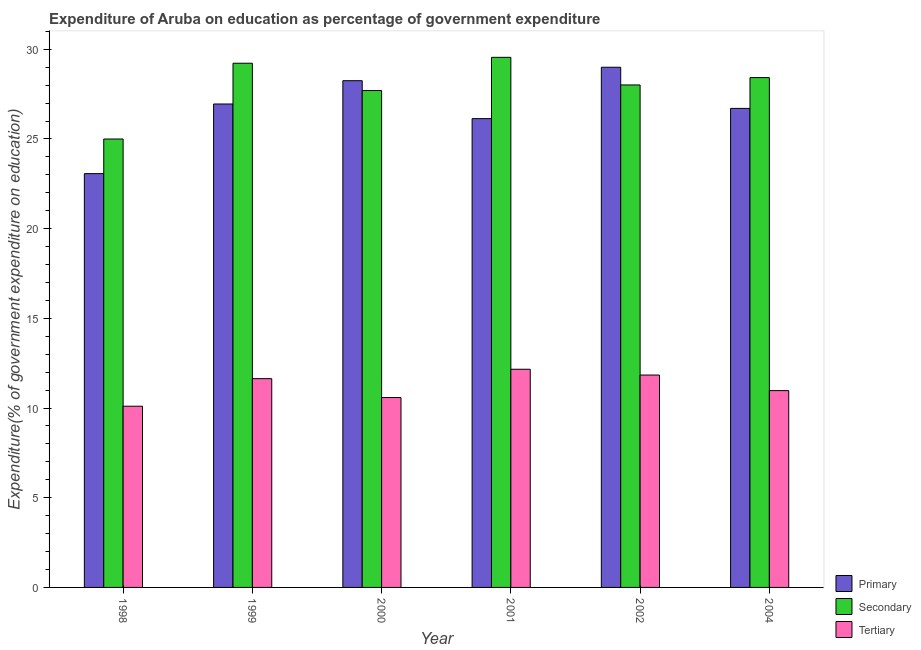Are the number of bars on each tick of the X-axis equal?
Keep it short and to the point. Yes. What is the label of the 6th group of bars from the left?
Your answer should be very brief. 2004. In how many cases, is the number of bars for a given year not equal to the number of legend labels?
Give a very brief answer. 0. What is the expenditure on secondary education in 2000?
Offer a terse response. 27.7. Across all years, what is the maximum expenditure on tertiary education?
Ensure brevity in your answer.  12.16. Across all years, what is the minimum expenditure on secondary education?
Your answer should be compact. 25. In which year was the expenditure on tertiary education maximum?
Your response must be concise. 2001. What is the total expenditure on secondary education in the graph?
Provide a short and direct response. 167.9. What is the difference between the expenditure on secondary education in 2000 and that in 2004?
Your answer should be very brief. -0.72. What is the difference between the expenditure on primary education in 2004 and the expenditure on secondary education in 2002?
Ensure brevity in your answer.  -2.29. What is the average expenditure on tertiary education per year?
Provide a short and direct response. 11.22. What is the ratio of the expenditure on primary education in 1999 to that in 2000?
Your answer should be compact. 0.95. Is the difference between the expenditure on tertiary education in 2000 and 2002 greater than the difference between the expenditure on secondary education in 2000 and 2002?
Offer a terse response. No. What is the difference between the highest and the second highest expenditure on primary education?
Make the answer very short. 0.75. What is the difference between the highest and the lowest expenditure on tertiary education?
Provide a succinct answer. 2.06. Is the sum of the expenditure on tertiary education in 2002 and 2004 greater than the maximum expenditure on secondary education across all years?
Your answer should be compact. Yes. What does the 3rd bar from the left in 2004 represents?
Ensure brevity in your answer.  Tertiary. What does the 2nd bar from the right in 1999 represents?
Your response must be concise. Secondary. Is it the case that in every year, the sum of the expenditure on primary education and expenditure on secondary education is greater than the expenditure on tertiary education?
Your answer should be very brief. Yes. Are all the bars in the graph horizontal?
Ensure brevity in your answer.  No. How many years are there in the graph?
Provide a short and direct response. 6. What is the difference between two consecutive major ticks on the Y-axis?
Give a very brief answer. 5. Where does the legend appear in the graph?
Give a very brief answer. Bottom right. How are the legend labels stacked?
Offer a very short reply. Vertical. What is the title of the graph?
Provide a short and direct response. Expenditure of Aruba on education as percentage of government expenditure. What is the label or title of the X-axis?
Keep it short and to the point. Year. What is the label or title of the Y-axis?
Provide a short and direct response. Expenditure(% of government expenditure on education). What is the Expenditure(% of government expenditure on education) of Primary in 1998?
Your response must be concise. 23.07. What is the Expenditure(% of government expenditure on education) in Secondary in 1998?
Provide a short and direct response. 25. What is the Expenditure(% of government expenditure on education) of Tertiary in 1998?
Make the answer very short. 10.1. What is the Expenditure(% of government expenditure on education) in Primary in 1999?
Make the answer very short. 26.95. What is the Expenditure(% of government expenditure on education) of Secondary in 1999?
Ensure brevity in your answer.  29.22. What is the Expenditure(% of government expenditure on education) of Tertiary in 1999?
Offer a very short reply. 11.64. What is the Expenditure(% of government expenditure on education) in Primary in 2000?
Keep it short and to the point. 28.25. What is the Expenditure(% of government expenditure on education) in Secondary in 2000?
Offer a very short reply. 27.7. What is the Expenditure(% of government expenditure on education) in Tertiary in 2000?
Keep it short and to the point. 10.58. What is the Expenditure(% of government expenditure on education) of Primary in 2001?
Provide a short and direct response. 26.13. What is the Expenditure(% of government expenditure on education) of Secondary in 2001?
Your response must be concise. 29.55. What is the Expenditure(% of government expenditure on education) in Tertiary in 2001?
Provide a succinct answer. 12.16. What is the Expenditure(% of government expenditure on education) in Primary in 2002?
Your response must be concise. 29. What is the Expenditure(% of government expenditure on education) in Secondary in 2002?
Your answer should be very brief. 28.01. What is the Expenditure(% of government expenditure on education) in Tertiary in 2002?
Keep it short and to the point. 11.84. What is the Expenditure(% of government expenditure on education) of Primary in 2004?
Make the answer very short. 26.7. What is the Expenditure(% of government expenditure on education) in Secondary in 2004?
Make the answer very short. 28.42. What is the Expenditure(% of government expenditure on education) of Tertiary in 2004?
Give a very brief answer. 10.97. Across all years, what is the maximum Expenditure(% of government expenditure on education) of Primary?
Your answer should be very brief. 29. Across all years, what is the maximum Expenditure(% of government expenditure on education) of Secondary?
Your answer should be compact. 29.55. Across all years, what is the maximum Expenditure(% of government expenditure on education) in Tertiary?
Your response must be concise. 12.16. Across all years, what is the minimum Expenditure(% of government expenditure on education) of Primary?
Provide a short and direct response. 23.07. Across all years, what is the minimum Expenditure(% of government expenditure on education) in Secondary?
Your response must be concise. 25. Across all years, what is the minimum Expenditure(% of government expenditure on education) in Tertiary?
Ensure brevity in your answer.  10.1. What is the total Expenditure(% of government expenditure on education) of Primary in the graph?
Ensure brevity in your answer.  160.1. What is the total Expenditure(% of government expenditure on education) in Secondary in the graph?
Provide a short and direct response. 167.9. What is the total Expenditure(% of government expenditure on education) in Tertiary in the graph?
Provide a short and direct response. 67.3. What is the difference between the Expenditure(% of government expenditure on education) of Primary in 1998 and that in 1999?
Offer a very short reply. -3.88. What is the difference between the Expenditure(% of government expenditure on education) in Secondary in 1998 and that in 1999?
Ensure brevity in your answer.  -4.22. What is the difference between the Expenditure(% of government expenditure on education) in Tertiary in 1998 and that in 1999?
Ensure brevity in your answer.  -1.54. What is the difference between the Expenditure(% of government expenditure on education) in Primary in 1998 and that in 2000?
Your answer should be compact. -5.18. What is the difference between the Expenditure(% of government expenditure on education) of Secondary in 1998 and that in 2000?
Keep it short and to the point. -2.7. What is the difference between the Expenditure(% of government expenditure on education) of Tertiary in 1998 and that in 2000?
Offer a terse response. -0.48. What is the difference between the Expenditure(% of government expenditure on education) in Primary in 1998 and that in 2001?
Ensure brevity in your answer.  -3.07. What is the difference between the Expenditure(% of government expenditure on education) of Secondary in 1998 and that in 2001?
Your answer should be very brief. -4.55. What is the difference between the Expenditure(% of government expenditure on education) of Tertiary in 1998 and that in 2001?
Provide a succinct answer. -2.06. What is the difference between the Expenditure(% of government expenditure on education) of Primary in 1998 and that in 2002?
Provide a succinct answer. -5.93. What is the difference between the Expenditure(% of government expenditure on education) in Secondary in 1998 and that in 2002?
Ensure brevity in your answer.  -3.01. What is the difference between the Expenditure(% of government expenditure on education) of Tertiary in 1998 and that in 2002?
Provide a short and direct response. -1.74. What is the difference between the Expenditure(% of government expenditure on education) of Primary in 1998 and that in 2004?
Your answer should be compact. -3.64. What is the difference between the Expenditure(% of government expenditure on education) of Secondary in 1998 and that in 2004?
Provide a succinct answer. -3.42. What is the difference between the Expenditure(% of government expenditure on education) in Tertiary in 1998 and that in 2004?
Your response must be concise. -0.87. What is the difference between the Expenditure(% of government expenditure on education) of Primary in 1999 and that in 2000?
Offer a terse response. -1.3. What is the difference between the Expenditure(% of government expenditure on education) in Secondary in 1999 and that in 2000?
Ensure brevity in your answer.  1.52. What is the difference between the Expenditure(% of government expenditure on education) of Tertiary in 1999 and that in 2000?
Ensure brevity in your answer.  1.05. What is the difference between the Expenditure(% of government expenditure on education) in Primary in 1999 and that in 2001?
Offer a very short reply. 0.82. What is the difference between the Expenditure(% of government expenditure on education) in Secondary in 1999 and that in 2001?
Your answer should be very brief. -0.33. What is the difference between the Expenditure(% of government expenditure on education) in Tertiary in 1999 and that in 2001?
Your answer should be compact. -0.52. What is the difference between the Expenditure(% of government expenditure on education) in Primary in 1999 and that in 2002?
Your answer should be very brief. -2.05. What is the difference between the Expenditure(% of government expenditure on education) in Secondary in 1999 and that in 2002?
Make the answer very short. 1.21. What is the difference between the Expenditure(% of government expenditure on education) in Tertiary in 1999 and that in 2002?
Ensure brevity in your answer.  -0.2. What is the difference between the Expenditure(% of government expenditure on education) of Primary in 1999 and that in 2004?
Your response must be concise. 0.25. What is the difference between the Expenditure(% of government expenditure on education) in Secondary in 1999 and that in 2004?
Ensure brevity in your answer.  0.8. What is the difference between the Expenditure(% of government expenditure on education) in Tertiary in 1999 and that in 2004?
Provide a short and direct response. 0.67. What is the difference between the Expenditure(% of government expenditure on education) of Primary in 2000 and that in 2001?
Your response must be concise. 2.11. What is the difference between the Expenditure(% of government expenditure on education) in Secondary in 2000 and that in 2001?
Your answer should be very brief. -1.85. What is the difference between the Expenditure(% of government expenditure on education) of Tertiary in 2000 and that in 2001?
Your response must be concise. -1.58. What is the difference between the Expenditure(% of government expenditure on education) of Primary in 2000 and that in 2002?
Give a very brief answer. -0.75. What is the difference between the Expenditure(% of government expenditure on education) in Secondary in 2000 and that in 2002?
Provide a short and direct response. -0.31. What is the difference between the Expenditure(% of government expenditure on education) in Tertiary in 2000 and that in 2002?
Ensure brevity in your answer.  -1.26. What is the difference between the Expenditure(% of government expenditure on education) in Primary in 2000 and that in 2004?
Offer a terse response. 1.54. What is the difference between the Expenditure(% of government expenditure on education) in Secondary in 2000 and that in 2004?
Ensure brevity in your answer.  -0.72. What is the difference between the Expenditure(% of government expenditure on education) of Tertiary in 2000 and that in 2004?
Offer a terse response. -0.39. What is the difference between the Expenditure(% of government expenditure on education) of Primary in 2001 and that in 2002?
Offer a very short reply. -2.86. What is the difference between the Expenditure(% of government expenditure on education) in Secondary in 2001 and that in 2002?
Provide a succinct answer. 1.54. What is the difference between the Expenditure(% of government expenditure on education) in Tertiary in 2001 and that in 2002?
Give a very brief answer. 0.32. What is the difference between the Expenditure(% of government expenditure on education) in Primary in 2001 and that in 2004?
Ensure brevity in your answer.  -0.57. What is the difference between the Expenditure(% of government expenditure on education) of Secondary in 2001 and that in 2004?
Your response must be concise. 1.13. What is the difference between the Expenditure(% of government expenditure on education) in Tertiary in 2001 and that in 2004?
Provide a succinct answer. 1.19. What is the difference between the Expenditure(% of government expenditure on education) in Primary in 2002 and that in 2004?
Your response must be concise. 2.29. What is the difference between the Expenditure(% of government expenditure on education) in Secondary in 2002 and that in 2004?
Give a very brief answer. -0.41. What is the difference between the Expenditure(% of government expenditure on education) in Tertiary in 2002 and that in 2004?
Make the answer very short. 0.87. What is the difference between the Expenditure(% of government expenditure on education) of Primary in 1998 and the Expenditure(% of government expenditure on education) of Secondary in 1999?
Ensure brevity in your answer.  -6.15. What is the difference between the Expenditure(% of government expenditure on education) in Primary in 1998 and the Expenditure(% of government expenditure on education) in Tertiary in 1999?
Your answer should be compact. 11.43. What is the difference between the Expenditure(% of government expenditure on education) of Secondary in 1998 and the Expenditure(% of government expenditure on education) of Tertiary in 1999?
Your answer should be compact. 13.36. What is the difference between the Expenditure(% of government expenditure on education) in Primary in 1998 and the Expenditure(% of government expenditure on education) in Secondary in 2000?
Offer a very short reply. -4.63. What is the difference between the Expenditure(% of government expenditure on education) in Primary in 1998 and the Expenditure(% of government expenditure on education) in Tertiary in 2000?
Your response must be concise. 12.48. What is the difference between the Expenditure(% of government expenditure on education) in Secondary in 1998 and the Expenditure(% of government expenditure on education) in Tertiary in 2000?
Make the answer very short. 14.41. What is the difference between the Expenditure(% of government expenditure on education) in Primary in 1998 and the Expenditure(% of government expenditure on education) in Secondary in 2001?
Offer a terse response. -6.48. What is the difference between the Expenditure(% of government expenditure on education) of Primary in 1998 and the Expenditure(% of government expenditure on education) of Tertiary in 2001?
Offer a very short reply. 10.9. What is the difference between the Expenditure(% of government expenditure on education) in Secondary in 1998 and the Expenditure(% of government expenditure on education) in Tertiary in 2001?
Your answer should be compact. 12.84. What is the difference between the Expenditure(% of government expenditure on education) in Primary in 1998 and the Expenditure(% of government expenditure on education) in Secondary in 2002?
Make the answer very short. -4.94. What is the difference between the Expenditure(% of government expenditure on education) in Primary in 1998 and the Expenditure(% of government expenditure on education) in Tertiary in 2002?
Give a very brief answer. 11.23. What is the difference between the Expenditure(% of government expenditure on education) in Secondary in 1998 and the Expenditure(% of government expenditure on education) in Tertiary in 2002?
Give a very brief answer. 13.16. What is the difference between the Expenditure(% of government expenditure on education) of Primary in 1998 and the Expenditure(% of government expenditure on education) of Secondary in 2004?
Your response must be concise. -5.35. What is the difference between the Expenditure(% of government expenditure on education) in Primary in 1998 and the Expenditure(% of government expenditure on education) in Tertiary in 2004?
Offer a terse response. 12.1. What is the difference between the Expenditure(% of government expenditure on education) in Secondary in 1998 and the Expenditure(% of government expenditure on education) in Tertiary in 2004?
Your answer should be compact. 14.03. What is the difference between the Expenditure(% of government expenditure on education) in Primary in 1999 and the Expenditure(% of government expenditure on education) in Secondary in 2000?
Your response must be concise. -0.75. What is the difference between the Expenditure(% of government expenditure on education) in Primary in 1999 and the Expenditure(% of government expenditure on education) in Tertiary in 2000?
Your response must be concise. 16.36. What is the difference between the Expenditure(% of government expenditure on education) in Secondary in 1999 and the Expenditure(% of government expenditure on education) in Tertiary in 2000?
Provide a succinct answer. 18.64. What is the difference between the Expenditure(% of government expenditure on education) of Primary in 1999 and the Expenditure(% of government expenditure on education) of Secondary in 2001?
Offer a terse response. -2.6. What is the difference between the Expenditure(% of government expenditure on education) in Primary in 1999 and the Expenditure(% of government expenditure on education) in Tertiary in 2001?
Keep it short and to the point. 14.79. What is the difference between the Expenditure(% of government expenditure on education) in Secondary in 1999 and the Expenditure(% of government expenditure on education) in Tertiary in 2001?
Provide a succinct answer. 17.06. What is the difference between the Expenditure(% of government expenditure on education) in Primary in 1999 and the Expenditure(% of government expenditure on education) in Secondary in 2002?
Your answer should be compact. -1.06. What is the difference between the Expenditure(% of government expenditure on education) of Primary in 1999 and the Expenditure(% of government expenditure on education) of Tertiary in 2002?
Make the answer very short. 15.11. What is the difference between the Expenditure(% of government expenditure on education) of Secondary in 1999 and the Expenditure(% of government expenditure on education) of Tertiary in 2002?
Provide a short and direct response. 17.38. What is the difference between the Expenditure(% of government expenditure on education) of Primary in 1999 and the Expenditure(% of government expenditure on education) of Secondary in 2004?
Give a very brief answer. -1.47. What is the difference between the Expenditure(% of government expenditure on education) in Primary in 1999 and the Expenditure(% of government expenditure on education) in Tertiary in 2004?
Keep it short and to the point. 15.98. What is the difference between the Expenditure(% of government expenditure on education) in Secondary in 1999 and the Expenditure(% of government expenditure on education) in Tertiary in 2004?
Your answer should be very brief. 18.25. What is the difference between the Expenditure(% of government expenditure on education) of Primary in 2000 and the Expenditure(% of government expenditure on education) of Secondary in 2001?
Offer a terse response. -1.3. What is the difference between the Expenditure(% of government expenditure on education) in Primary in 2000 and the Expenditure(% of government expenditure on education) in Tertiary in 2001?
Make the answer very short. 16.09. What is the difference between the Expenditure(% of government expenditure on education) of Secondary in 2000 and the Expenditure(% of government expenditure on education) of Tertiary in 2001?
Offer a very short reply. 15.54. What is the difference between the Expenditure(% of government expenditure on education) of Primary in 2000 and the Expenditure(% of government expenditure on education) of Secondary in 2002?
Your answer should be compact. 0.24. What is the difference between the Expenditure(% of government expenditure on education) in Primary in 2000 and the Expenditure(% of government expenditure on education) in Tertiary in 2002?
Your answer should be very brief. 16.41. What is the difference between the Expenditure(% of government expenditure on education) of Secondary in 2000 and the Expenditure(% of government expenditure on education) of Tertiary in 2002?
Your answer should be compact. 15.86. What is the difference between the Expenditure(% of government expenditure on education) in Primary in 2000 and the Expenditure(% of government expenditure on education) in Secondary in 2004?
Give a very brief answer. -0.17. What is the difference between the Expenditure(% of government expenditure on education) of Primary in 2000 and the Expenditure(% of government expenditure on education) of Tertiary in 2004?
Provide a succinct answer. 17.28. What is the difference between the Expenditure(% of government expenditure on education) in Secondary in 2000 and the Expenditure(% of government expenditure on education) in Tertiary in 2004?
Give a very brief answer. 16.73. What is the difference between the Expenditure(% of government expenditure on education) of Primary in 2001 and the Expenditure(% of government expenditure on education) of Secondary in 2002?
Offer a terse response. -1.88. What is the difference between the Expenditure(% of government expenditure on education) of Primary in 2001 and the Expenditure(% of government expenditure on education) of Tertiary in 2002?
Your response must be concise. 14.29. What is the difference between the Expenditure(% of government expenditure on education) of Secondary in 2001 and the Expenditure(% of government expenditure on education) of Tertiary in 2002?
Ensure brevity in your answer.  17.71. What is the difference between the Expenditure(% of government expenditure on education) in Primary in 2001 and the Expenditure(% of government expenditure on education) in Secondary in 2004?
Offer a terse response. -2.29. What is the difference between the Expenditure(% of government expenditure on education) of Primary in 2001 and the Expenditure(% of government expenditure on education) of Tertiary in 2004?
Keep it short and to the point. 15.16. What is the difference between the Expenditure(% of government expenditure on education) of Secondary in 2001 and the Expenditure(% of government expenditure on education) of Tertiary in 2004?
Your response must be concise. 18.58. What is the difference between the Expenditure(% of government expenditure on education) in Primary in 2002 and the Expenditure(% of government expenditure on education) in Secondary in 2004?
Your response must be concise. 0.58. What is the difference between the Expenditure(% of government expenditure on education) of Primary in 2002 and the Expenditure(% of government expenditure on education) of Tertiary in 2004?
Your answer should be very brief. 18.03. What is the difference between the Expenditure(% of government expenditure on education) of Secondary in 2002 and the Expenditure(% of government expenditure on education) of Tertiary in 2004?
Your answer should be compact. 17.04. What is the average Expenditure(% of government expenditure on education) of Primary per year?
Your answer should be very brief. 26.68. What is the average Expenditure(% of government expenditure on education) of Secondary per year?
Your response must be concise. 27.98. What is the average Expenditure(% of government expenditure on education) of Tertiary per year?
Ensure brevity in your answer.  11.22. In the year 1998, what is the difference between the Expenditure(% of government expenditure on education) in Primary and Expenditure(% of government expenditure on education) in Secondary?
Make the answer very short. -1.93. In the year 1998, what is the difference between the Expenditure(% of government expenditure on education) in Primary and Expenditure(% of government expenditure on education) in Tertiary?
Your response must be concise. 12.97. In the year 1998, what is the difference between the Expenditure(% of government expenditure on education) in Secondary and Expenditure(% of government expenditure on education) in Tertiary?
Offer a terse response. 14.9. In the year 1999, what is the difference between the Expenditure(% of government expenditure on education) in Primary and Expenditure(% of government expenditure on education) in Secondary?
Offer a terse response. -2.27. In the year 1999, what is the difference between the Expenditure(% of government expenditure on education) of Primary and Expenditure(% of government expenditure on education) of Tertiary?
Offer a very short reply. 15.31. In the year 1999, what is the difference between the Expenditure(% of government expenditure on education) in Secondary and Expenditure(% of government expenditure on education) in Tertiary?
Your answer should be compact. 17.58. In the year 2000, what is the difference between the Expenditure(% of government expenditure on education) in Primary and Expenditure(% of government expenditure on education) in Secondary?
Your answer should be very brief. 0.55. In the year 2000, what is the difference between the Expenditure(% of government expenditure on education) in Primary and Expenditure(% of government expenditure on education) in Tertiary?
Make the answer very short. 17.66. In the year 2000, what is the difference between the Expenditure(% of government expenditure on education) of Secondary and Expenditure(% of government expenditure on education) of Tertiary?
Make the answer very short. 17.11. In the year 2001, what is the difference between the Expenditure(% of government expenditure on education) in Primary and Expenditure(% of government expenditure on education) in Secondary?
Your answer should be compact. -3.42. In the year 2001, what is the difference between the Expenditure(% of government expenditure on education) of Primary and Expenditure(% of government expenditure on education) of Tertiary?
Provide a succinct answer. 13.97. In the year 2001, what is the difference between the Expenditure(% of government expenditure on education) of Secondary and Expenditure(% of government expenditure on education) of Tertiary?
Provide a short and direct response. 17.39. In the year 2002, what is the difference between the Expenditure(% of government expenditure on education) of Primary and Expenditure(% of government expenditure on education) of Secondary?
Your answer should be compact. 0.99. In the year 2002, what is the difference between the Expenditure(% of government expenditure on education) of Primary and Expenditure(% of government expenditure on education) of Tertiary?
Keep it short and to the point. 17.16. In the year 2002, what is the difference between the Expenditure(% of government expenditure on education) of Secondary and Expenditure(% of government expenditure on education) of Tertiary?
Provide a succinct answer. 16.17. In the year 2004, what is the difference between the Expenditure(% of government expenditure on education) of Primary and Expenditure(% of government expenditure on education) of Secondary?
Provide a succinct answer. -1.72. In the year 2004, what is the difference between the Expenditure(% of government expenditure on education) in Primary and Expenditure(% of government expenditure on education) in Tertiary?
Your answer should be very brief. 15.73. In the year 2004, what is the difference between the Expenditure(% of government expenditure on education) of Secondary and Expenditure(% of government expenditure on education) of Tertiary?
Offer a very short reply. 17.45. What is the ratio of the Expenditure(% of government expenditure on education) in Primary in 1998 to that in 1999?
Offer a very short reply. 0.86. What is the ratio of the Expenditure(% of government expenditure on education) of Secondary in 1998 to that in 1999?
Provide a succinct answer. 0.86. What is the ratio of the Expenditure(% of government expenditure on education) of Tertiary in 1998 to that in 1999?
Make the answer very short. 0.87. What is the ratio of the Expenditure(% of government expenditure on education) in Primary in 1998 to that in 2000?
Provide a succinct answer. 0.82. What is the ratio of the Expenditure(% of government expenditure on education) in Secondary in 1998 to that in 2000?
Offer a very short reply. 0.9. What is the ratio of the Expenditure(% of government expenditure on education) in Tertiary in 1998 to that in 2000?
Offer a terse response. 0.95. What is the ratio of the Expenditure(% of government expenditure on education) in Primary in 1998 to that in 2001?
Keep it short and to the point. 0.88. What is the ratio of the Expenditure(% of government expenditure on education) of Secondary in 1998 to that in 2001?
Ensure brevity in your answer.  0.85. What is the ratio of the Expenditure(% of government expenditure on education) of Tertiary in 1998 to that in 2001?
Offer a very short reply. 0.83. What is the ratio of the Expenditure(% of government expenditure on education) of Primary in 1998 to that in 2002?
Your answer should be very brief. 0.8. What is the ratio of the Expenditure(% of government expenditure on education) of Secondary in 1998 to that in 2002?
Your response must be concise. 0.89. What is the ratio of the Expenditure(% of government expenditure on education) of Tertiary in 1998 to that in 2002?
Provide a short and direct response. 0.85. What is the ratio of the Expenditure(% of government expenditure on education) in Primary in 1998 to that in 2004?
Offer a very short reply. 0.86. What is the ratio of the Expenditure(% of government expenditure on education) in Secondary in 1998 to that in 2004?
Your answer should be compact. 0.88. What is the ratio of the Expenditure(% of government expenditure on education) of Tertiary in 1998 to that in 2004?
Make the answer very short. 0.92. What is the ratio of the Expenditure(% of government expenditure on education) of Primary in 1999 to that in 2000?
Give a very brief answer. 0.95. What is the ratio of the Expenditure(% of government expenditure on education) in Secondary in 1999 to that in 2000?
Your answer should be compact. 1.05. What is the ratio of the Expenditure(% of government expenditure on education) in Tertiary in 1999 to that in 2000?
Your answer should be very brief. 1.1. What is the ratio of the Expenditure(% of government expenditure on education) in Primary in 1999 to that in 2001?
Provide a succinct answer. 1.03. What is the ratio of the Expenditure(% of government expenditure on education) of Secondary in 1999 to that in 2001?
Provide a short and direct response. 0.99. What is the ratio of the Expenditure(% of government expenditure on education) in Tertiary in 1999 to that in 2001?
Provide a succinct answer. 0.96. What is the ratio of the Expenditure(% of government expenditure on education) in Primary in 1999 to that in 2002?
Provide a succinct answer. 0.93. What is the ratio of the Expenditure(% of government expenditure on education) of Secondary in 1999 to that in 2002?
Make the answer very short. 1.04. What is the ratio of the Expenditure(% of government expenditure on education) of Tertiary in 1999 to that in 2002?
Your response must be concise. 0.98. What is the ratio of the Expenditure(% of government expenditure on education) of Primary in 1999 to that in 2004?
Your answer should be very brief. 1.01. What is the ratio of the Expenditure(% of government expenditure on education) in Secondary in 1999 to that in 2004?
Your answer should be very brief. 1.03. What is the ratio of the Expenditure(% of government expenditure on education) of Tertiary in 1999 to that in 2004?
Offer a very short reply. 1.06. What is the ratio of the Expenditure(% of government expenditure on education) in Primary in 2000 to that in 2001?
Your response must be concise. 1.08. What is the ratio of the Expenditure(% of government expenditure on education) of Secondary in 2000 to that in 2001?
Your response must be concise. 0.94. What is the ratio of the Expenditure(% of government expenditure on education) of Tertiary in 2000 to that in 2001?
Keep it short and to the point. 0.87. What is the ratio of the Expenditure(% of government expenditure on education) of Primary in 2000 to that in 2002?
Your answer should be very brief. 0.97. What is the ratio of the Expenditure(% of government expenditure on education) in Tertiary in 2000 to that in 2002?
Provide a short and direct response. 0.89. What is the ratio of the Expenditure(% of government expenditure on education) in Primary in 2000 to that in 2004?
Provide a succinct answer. 1.06. What is the ratio of the Expenditure(% of government expenditure on education) in Secondary in 2000 to that in 2004?
Make the answer very short. 0.97. What is the ratio of the Expenditure(% of government expenditure on education) in Tertiary in 2000 to that in 2004?
Your response must be concise. 0.96. What is the ratio of the Expenditure(% of government expenditure on education) of Primary in 2001 to that in 2002?
Offer a very short reply. 0.9. What is the ratio of the Expenditure(% of government expenditure on education) in Secondary in 2001 to that in 2002?
Keep it short and to the point. 1.05. What is the ratio of the Expenditure(% of government expenditure on education) of Tertiary in 2001 to that in 2002?
Keep it short and to the point. 1.03. What is the ratio of the Expenditure(% of government expenditure on education) of Primary in 2001 to that in 2004?
Offer a very short reply. 0.98. What is the ratio of the Expenditure(% of government expenditure on education) of Secondary in 2001 to that in 2004?
Provide a succinct answer. 1.04. What is the ratio of the Expenditure(% of government expenditure on education) of Tertiary in 2001 to that in 2004?
Your response must be concise. 1.11. What is the ratio of the Expenditure(% of government expenditure on education) of Primary in 2002 to that in 2004?
Give a very brief answer. 1.09. What is the ratio of the Expenditure(% of government expenditure on education) in Secondary in 2002 to that in 2004?
Your response must be concise. 0.99. What is the ratio of the Expenditure(% of government expenditure on education) of Tertiary in 2002 to that in 2004?
Give a very brief answer. 1.08. What is the difference between the highest and the second highest Expenditure(% of government expenditure on education) in Primary?
Make the answer very short. 0.75. What is the difference between the highest and the second highest Expenditure(% of government expenditure on education) in Secondary?
Offer a very short reply. 0.33. What is the difference between the highest and the second highest Expenditure(% of government expenditure on education) in Tertiary?
Give a very brief answer. 0.32. What is the difference between the highest and the lowest Expenditure(% of government expenditure on education) in Primary?
Your answer should be compact. 5.93. What is the difference between the highest and the lowest Expenditure(% of government expenditure on education) in Secondary?
Keep it short and to the point. 4.55. What is the difference between the highest and the lowest Expenditure(% of government expenditure on education) in Tertiary?
Your answer should be compact. 2.06. 